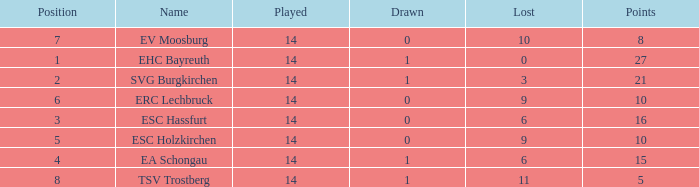What's the points that has a lost more 6, played less than 14 and a position more than 1? None. 